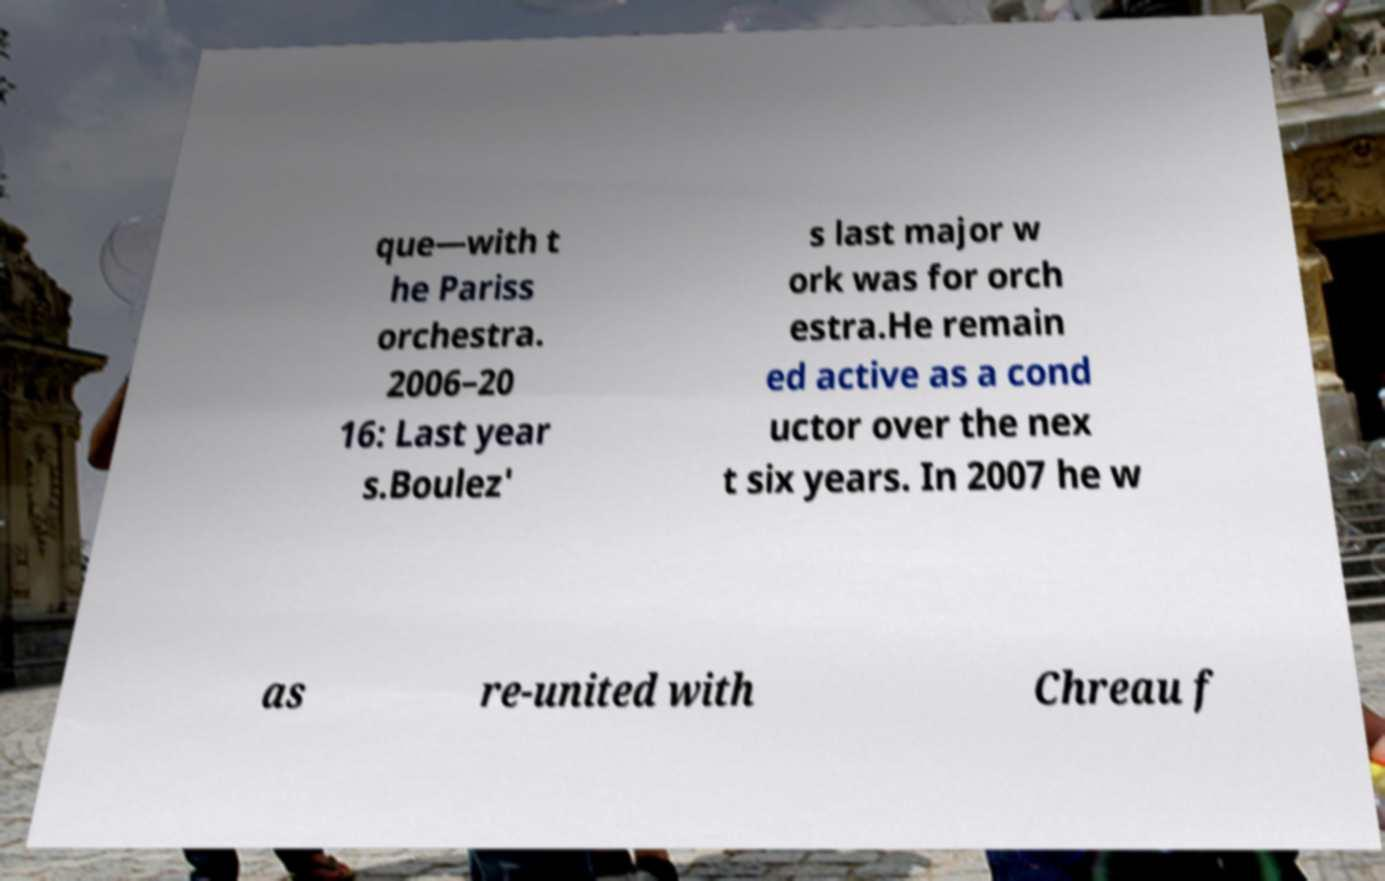For documentation purposes, I need the text within this image transcribed. Could you provide that? que—with t he Pariss orchestra. 2006–20 16: Last year s.Boulez' s last major w ork was for orch estra.He remain ed active as a cond uctor over the nex t six years. In 2007 he w as re-united with Chreau f 